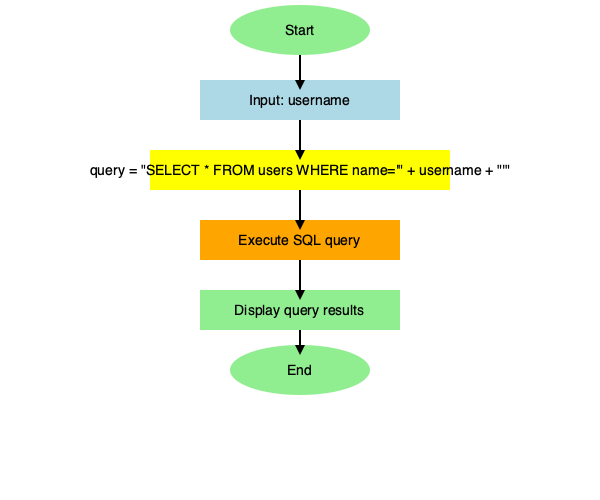Analyze the flowchart representing a C++ code snippet for user authentication. Identify the step that introduces a potential SQL injection vulnerability and explain how an attacker could exploit it. To identify the SQL injection vulnerability in this flowchart, we need to analyze each step:

1. The process starts with inputting a username.
2. The critical vulnerability is introduced in the query construction step, where the username is directly concatenated into the SQL query string without any form of sanitization or parameterization.
3. The constructed query is then executed, and the results are displayed.

The vulnerability lies in the query construction step because:

a) The username input is directly inserted into the SQL query string without any validation or sanitization.
b) An attacker can input specially crafted strings to manipulate the query's logic.

For example, if an attacker inputs the username: `' OR '1'='1`, the resulting query would be:

```sql
SELECT * FROM users WHERE name='' OR '1'='1'
```

This query will always return true, potentially allowing the attacker to bypass authentication and access all user records.

To prevent this vulnerability, the code should use parameterized queries or prepared statements instead of direct string concatenation. Additionally, input validation and sanitization should be implemented to reject or escape potentially dangerous characters.
Answer: Query construction step (yellow box) 